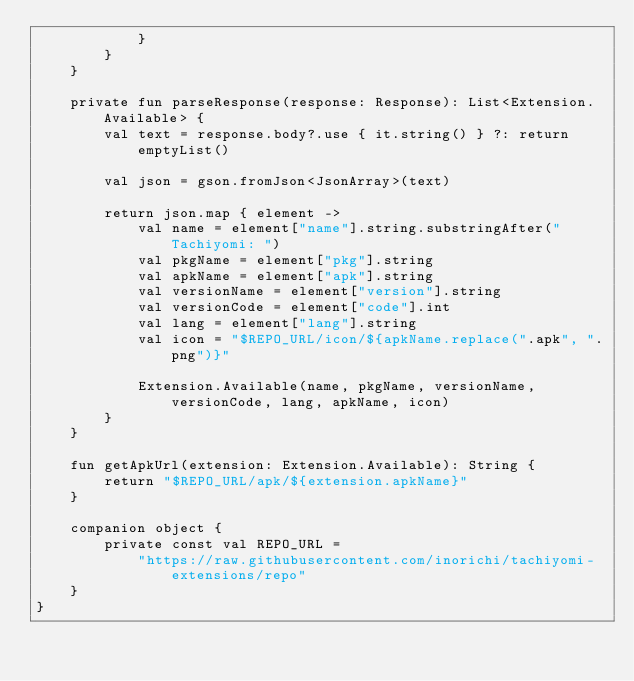Convert code to text. <code><loc_0><loc_0><loc_500><loc_500><_Kotlin_>            }
        }
    }

    private fun parseResponse(response: Response): List<Extension.Available> {
        val text = response.body?.use { it.string() } ?: return emptyList()

        val json = gson.fromJson<JsonArray>(text)

        return json.map { element ->
            val name = element["name"].string.substringAfter("Tachiyomi: ")
            val pkgName = element["pkg"].string
            val apkName = element["apk"].string
            val versionName = element["version"].string
            val versionCode = element["code"].int
            val lang = element["lang"].string
            val icon = "$REPO_URL/icon/${apkName.replace(".apk", ".png")}"

            Extension.Available(name, pkgName, versionName, versionCode, lang, apkName, icon)
        }
    }

    fun getApkUrl(extension: Extension.Available): String {
        return "$REPO_URL/apk/${extension.apkName}"
    }

    companion object {
        private const val REPO_URL =
            "https://raw.githubusercontent.com/inorichi/tachiyomi-extensions/repo"
    }
}
</code> 